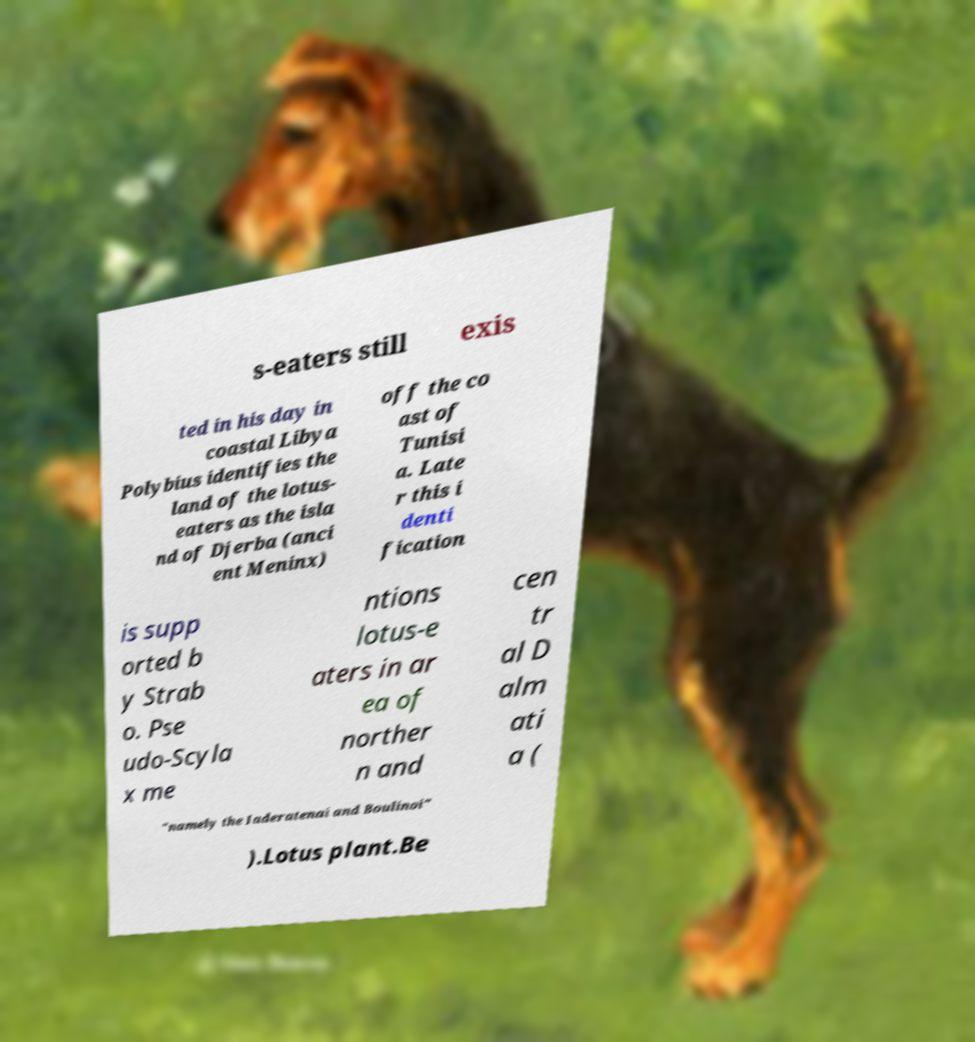Please identify and transcribe the text found in this image. s-eaters still exis ted in his day in coastal Libya Polybius identifies the land of the lotus- eaters as the isla nd of Djerba (anci ent Meninx) off the co ast of Tunisi a. Late r this i denti fication is supp orted b y Strab o. Pse udo-Scyla x me ntions lotus-e aters in ar ea of norther n and cen tr al D alm ati a ( "namely the Iaderatenai and Boulinoi" ).Lotus plant.Be 